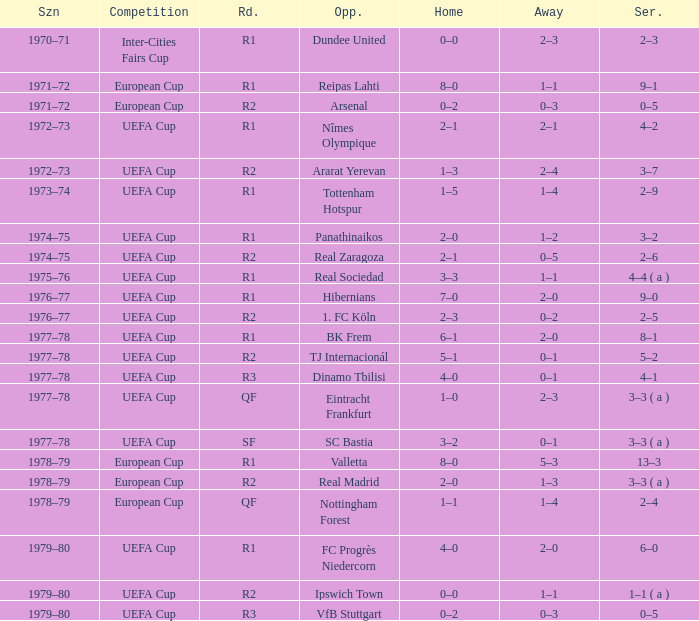Which Opponent has an Away of 1–1, and a Home of 3–3? Real Sociedad. 